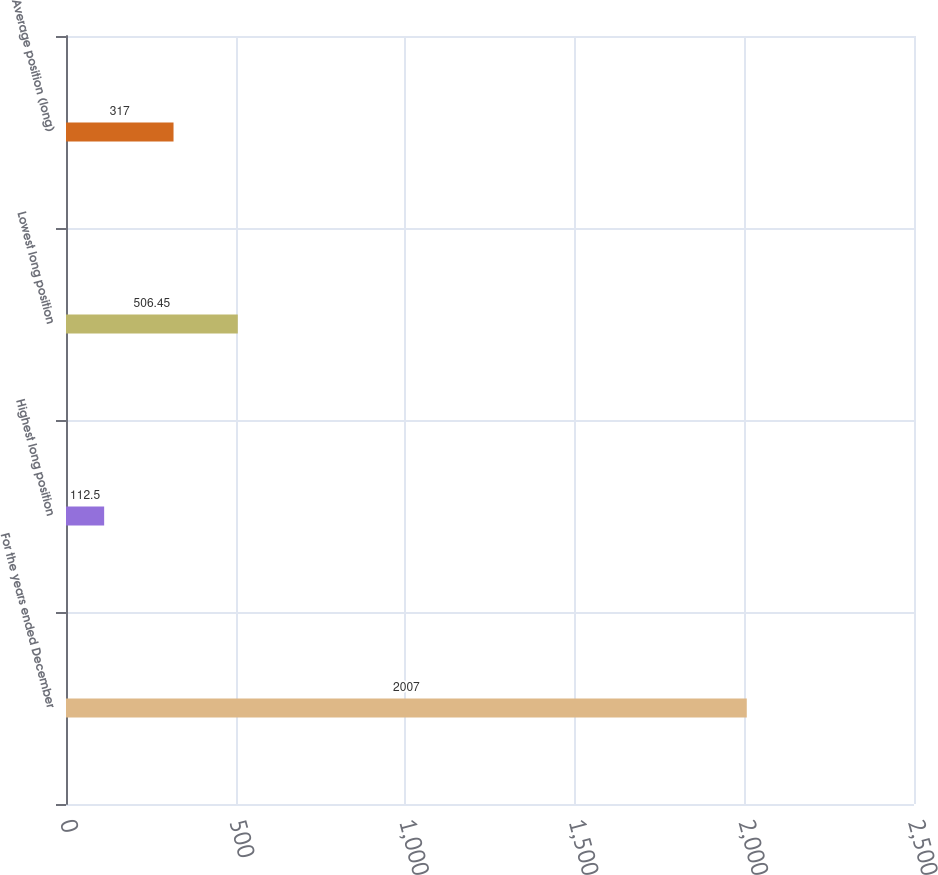Convert chart to OTSL. <chart><loc_0><loc_0><loc_500><loc_500><bar_chart><fcel>For the years ended December<fcel>Highest long position<fcel>Lowest long position<fcel>Average position (long)<nl><fcel>2007<fcel>112.5<fcel>506.45<fcel>317<nl></chart> 